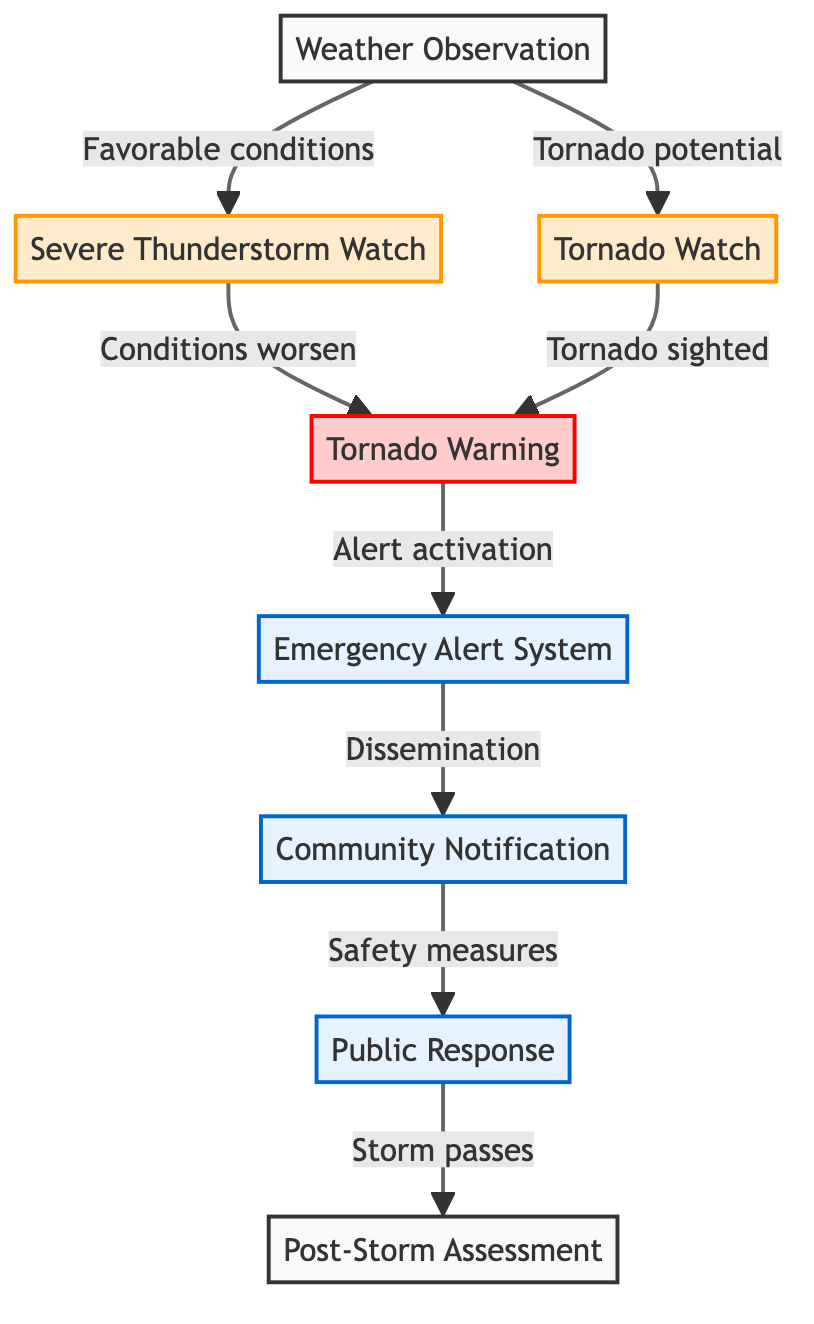What starts the storm reporting process? The process begins with weather observation by meteorologists monitoring weather patterns using radar and satellite technology.
Answer: Weather Observation How many types of watches are there in this diagram? There are two types of watches indicated in the flowchart: the Severe Thunderstorm Watch and the Tornado Watch.
Answer: 2 What follows a Tornado Watch? A Tornado Warning follows when a tornado is sighted or indicated by radar.
Answer: Tornado Warning What system is activated for alert dissemination? The Emergency Alert System is activated for disseminating alerts to the public.
Answer: Emergency Alert System What action do residents take after receiving the community notification? Residents take safety measures, which include seeking shelter or evacuating if necessary.
Answer: Safety measures What is assessed after the storm passes? Post-storm assessment is conducted to evaluate damages and response in affected communities.
Answer: Post-Storm Assessment What indicates conditions are favorable for severe thunderstorms? A Severe Thunderstorm Watch is issued to indicate favorable conditions for severe thunderstorms.
Answer: Severe Thunderstorm Watch Which step occurs if tornado potential is noted? If tornado potential is noted, a Tornado Watch is issued by the National Weather Service.
Answer: Tornado Watch How is the community notified about storm alerts? Communities receive alerts through various channels such as sirens, texts, and social media.
Answer: Community Notification 